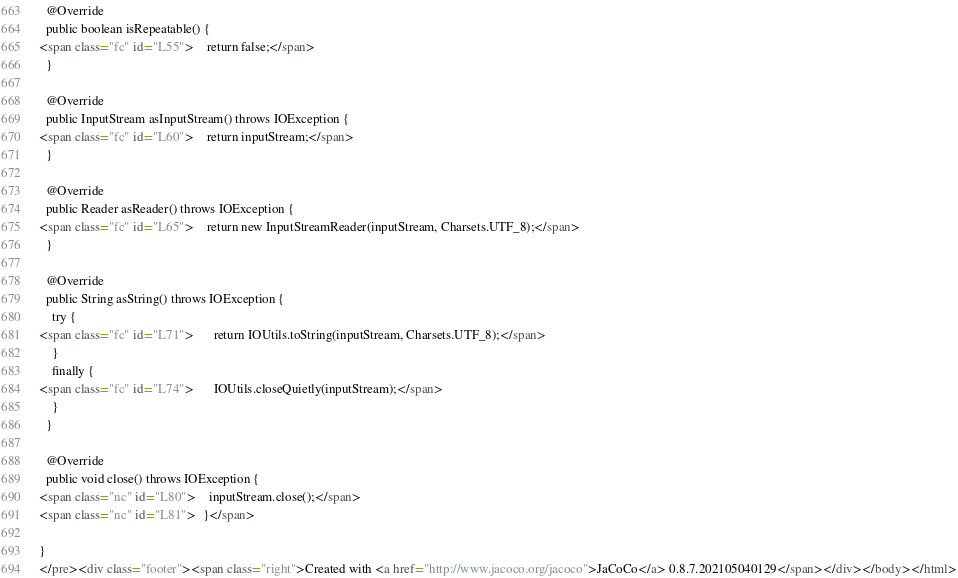Convert code to text. <code><loc_0><loc_0><loc_500><loc_500><_HTML_>
  @Override
  public boolean isRepeatable() {
<span class="fc" id="L55">    return false;</span>
  }

  @Override
  public InputStream asInputStream() throws IOException {
<span class="fc" id="L60">    return inputStream;</span>
  }

  @Override
  public Reader asReader() throws IOException {
<span class="fc" id="L65">    return new InputStreamReader(inputStream, Charsets.UTF_8);</span>
  }

  @Override
  public String asString() throws IOException {
    try {
<span class="fc" id="L71">      return IOUtils.toString(inputStream, Charsets.UTF_8);</span>
    }
    finally {
<span class="fc" id="L74">      IOUtils.closeQuietly(inputStream);</span>
    }
  }

  @Override
  public void close() throws IOException {
<span class="nc" id="L80">    inputStream.close();</span>
<span class="nc" id="L81">  }</span>

}
</pre><div class="footer"><span class="right">Created with <a href="http://www.jacoco.org/jacoco">JaCoCo</a> 0.8.7.202105040129</span></div></body></html></code> 